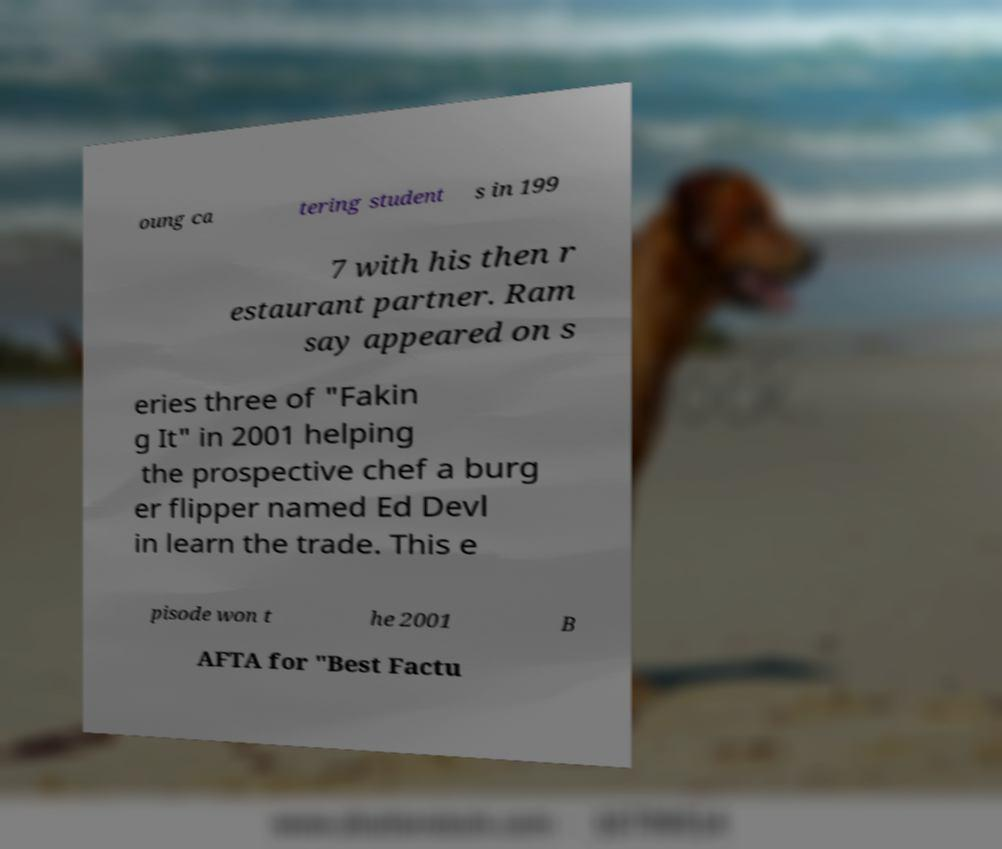Could you extract and type out the text from this image? oung ca tering student s in 199 7 with his then r estaurant partner. Ram say appeared on s eries three of "Fakin g It" in 2001 helping the prospective chef a burg er flipper named Ed Devl in learn the trade. This e pisode won t he 2001 B AFTA for "Best Factu 